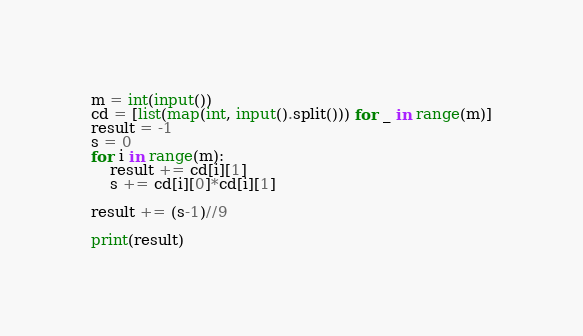Convert code to text. <code><loc_0><loc_0><loc_500><loc_500><_Python_>m = int(input())
cd = [list(map(int, input().split())) for _ in range(m)]
result = -1
s = 0
for i in range(m):
    result += cd[i][1]
    s += cd[i][0]*cd[i][1]

result += (s-1)//9

print(result)</code> 